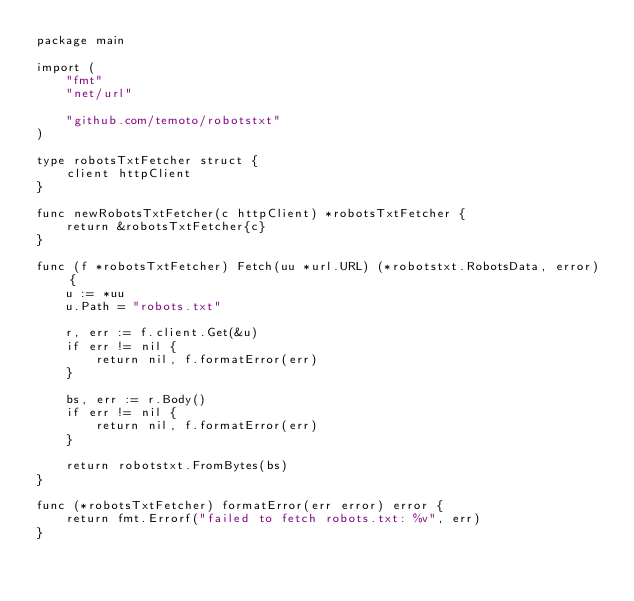Convert code to text. <code><loc_0><loc_0><loc_500><loc_500><_Go_>package main

import (
	"fmt"
	"net/url"

	"github.com/temoto/robotstxt"
)

type robotsTxtFetcher struct {
	client httpClient
}

func newRobotsTxtFetcher(c httpClient) *robotsTxtFetcher {
	return &robotsTxtFetcher{c}
}

func (f *robotsTxtFetcher) Fetch(uu *url.URL) (*robotstxt.RobotsData, error) {
	u := *uu
	u.Path = "robots.txt"

	r, err := f.client.Get(&u)
	if err != nil {
		return nil, f.formatError(err)
	}

	bs, err := r.Body()
	if err != nil {
		return nil, f.formatError(err)
	}

	return robotstxt.FromBytes(bs)
}

func (*robotsTxtFetcher) formatError(err error) error {
	return fmt.Errorf("failed to fetch robots.txt: %v", err)
}
</code> 